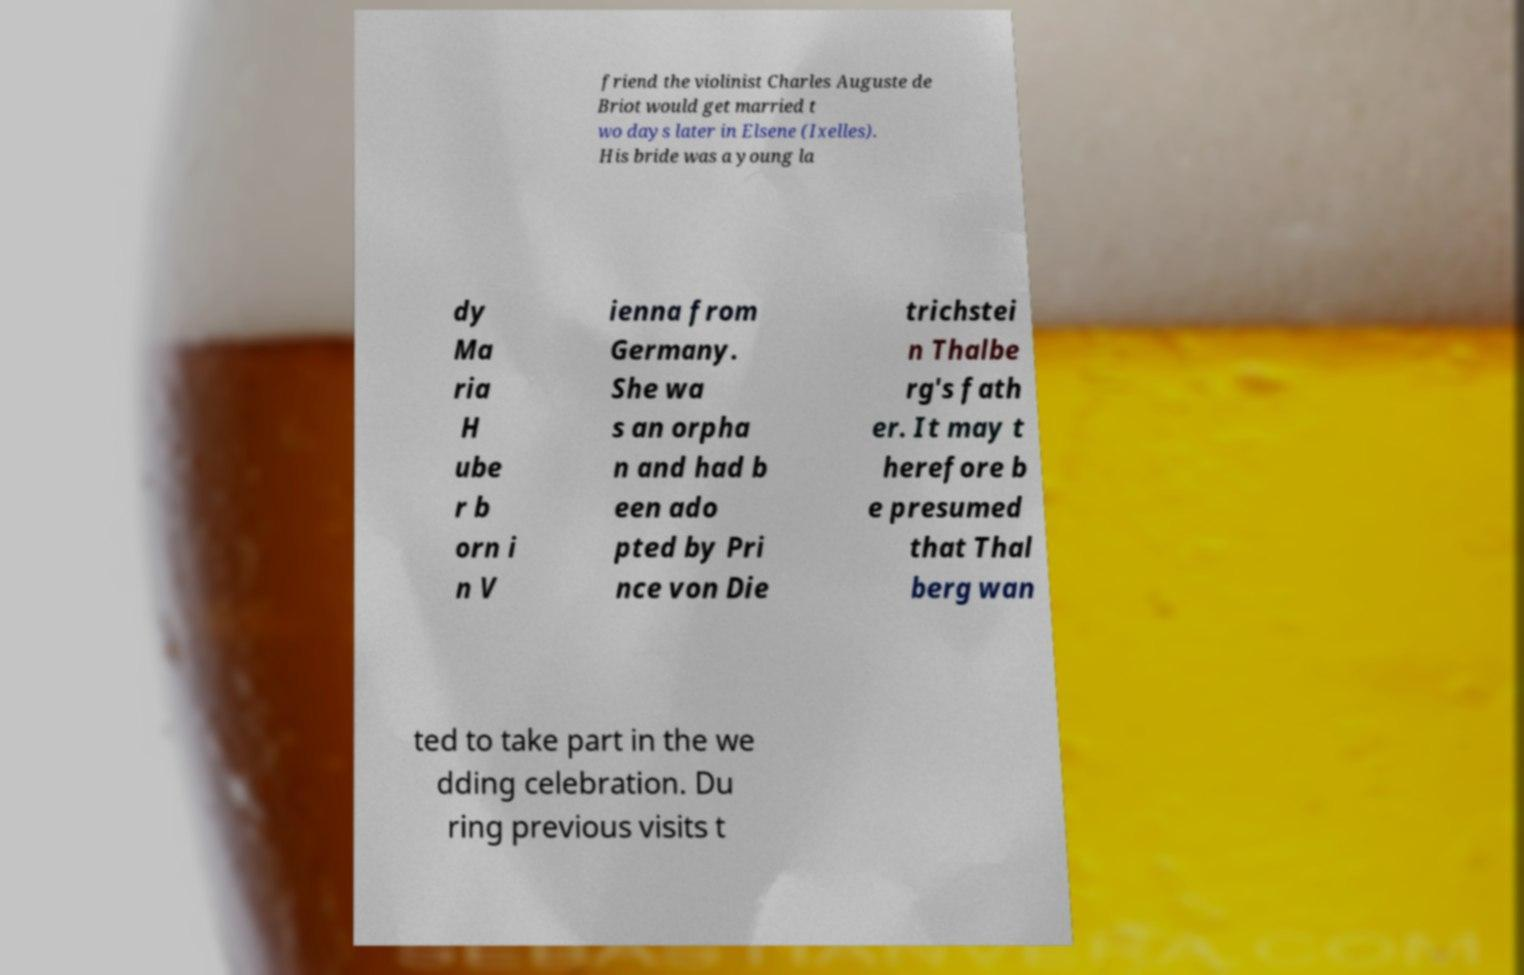Can you accurately transcribe the text from the provided image for me? friend the violinist Charles Auguste de Briot would get married t wo days later in Elsene (Ixelles). His bride was a young la dy Ma ria H ube r b orn i n V ienna from Germany. She wa s an orpha n and had b een ado pted by Pri nce von Die trichstei n Thalbe rg's fath er. It may t herefore b e presumed that Thal berg wan ted to take part in the we dding celebration. Du ring previous visits t 